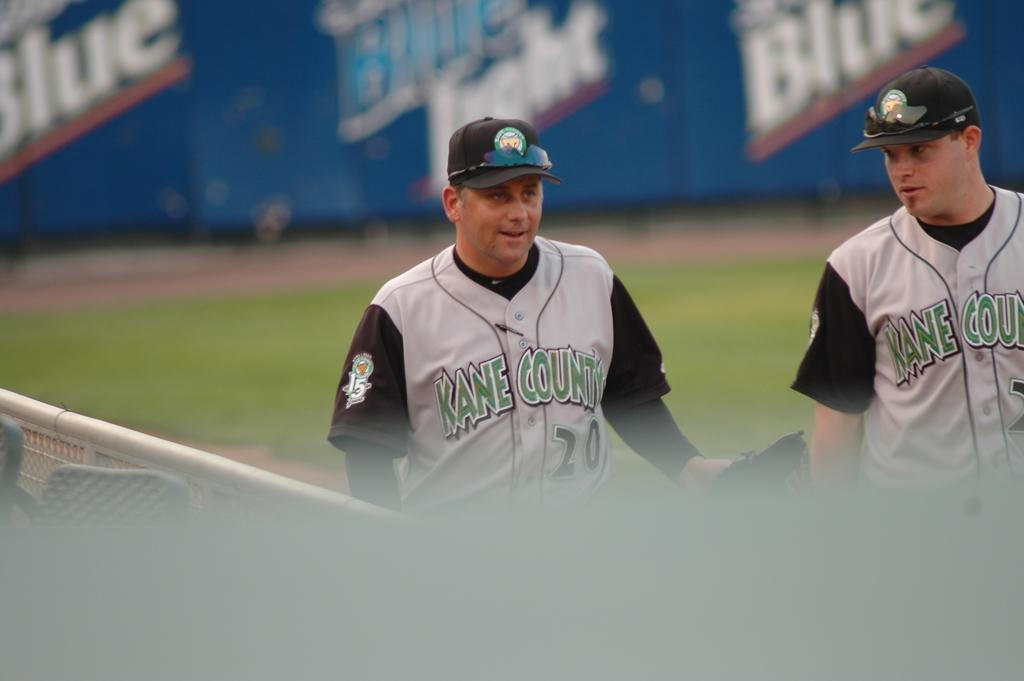Provide a one-sentence caption for the provided image. two baseball players wearing jerseys from Kane County. 